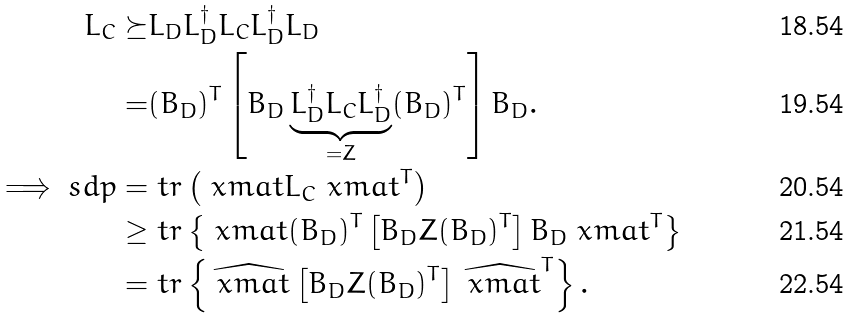<formula> <loc_0><loc_0><loc_500><loc_500>L _ { C } \succeq & L _ { D } L _ { D } ^ { \dagger } L _ { C } L _ { D } ^ { \dagger } L _ { D } \\ = & ( B _ { D } ) ^ { T } \left [ B _ { D } \underbrace { L _ { D } ^ { \dagger } L _ { C } L _ { D } ^ { \dagger } } _ { = Z } ( B _ { D } ) ^ { T } \right ] B _ { D } . \\ \implies s d p = & \ t r \left ( \ x m a t L _ { C } \ x m a t ^ { T } \right ) \\ \geq & \ t r \left \{ \ x m a t ( B _ { D } ) ^ { T } \left [ B _ { D } Z ( B _ { D } ) ^ { T } \right ] B _ { D } \ x m a t ^ { T } \right \} \\ = & \ t r \left \{ \widehat { \ x m a t } \left [ B _ { D } Z ( B _ { D } ) ^ { T } \right ] \widehat { \ x m a t } ^ { T } \right \} .</formula> 